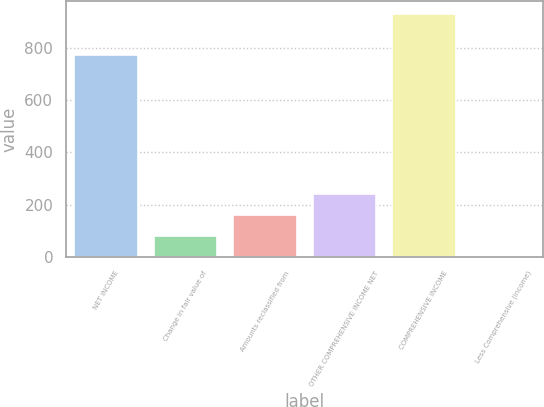<chart> <loc_0><loc_0><loc_500><loc_500><bar_chart><fcel>NET INCOME<fcel>Change in fair value of<fcel>Amounts reclassified from<fcel>OTHER COMPREHENSIVE INCOME NET<fcel>COMPREHENSIVE INCOME<fcel>Less Comprehensive (income)<nl><fcel>771<fcel>80.5<fcel>160<fcel>239.5<fcel>930<fcel>1<nl></chart> 